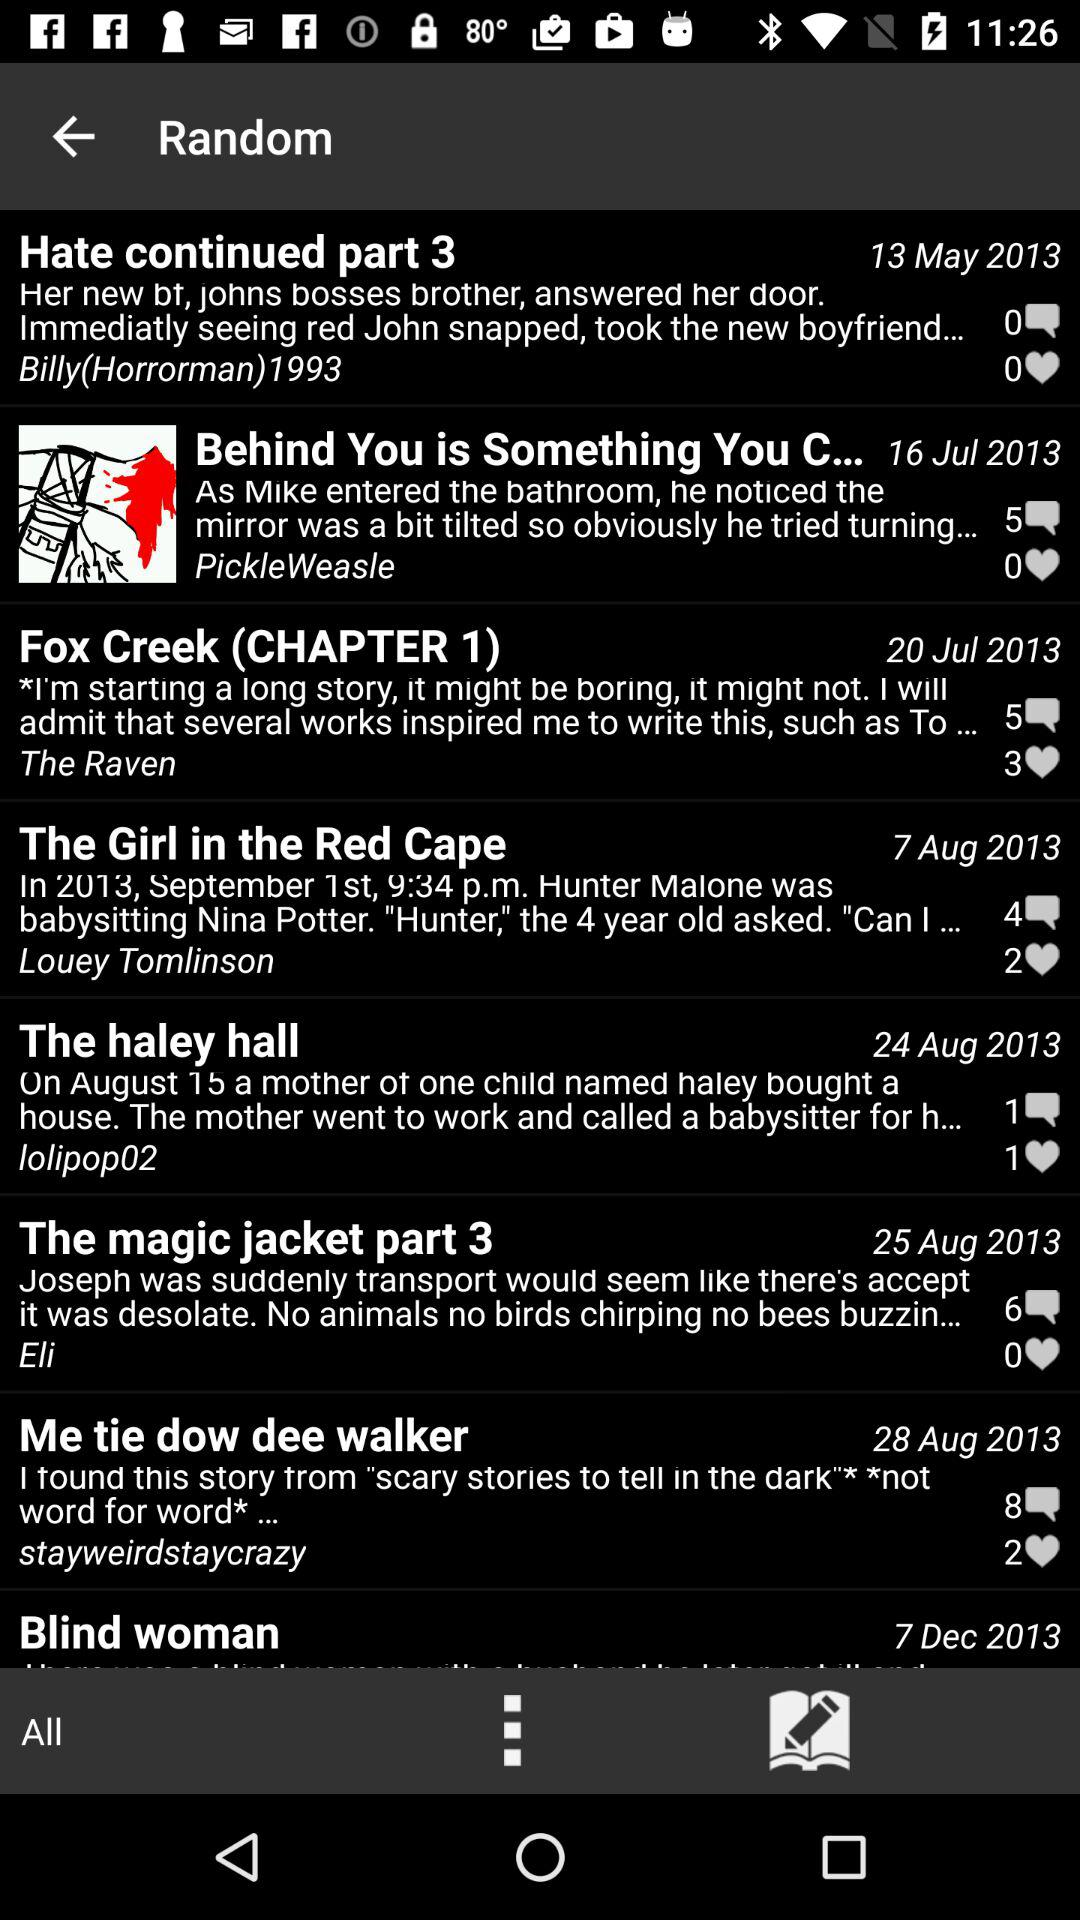Which post has 8 comments? The post is "Me tie dow dee walker". 